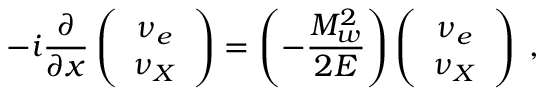Convert formula to latex. <formula><loc_0><loc_0><loc_500><loc_500>- i \frac { \partial } { \partial x } \left ( \begin{array} { c } { { { \nu _ { e } } } } \\ { { { \nu _ { X } } } } \end{array} \right ) = \left ( - \frac { M _ { w } ^ { 2 } } { 2 E } \right ) \left ( \begin{array} { c } { { { \nu _ { e } } } } \\ { { { \nu _ { X } } } } \end{array} \right ) \, ,</formula> 